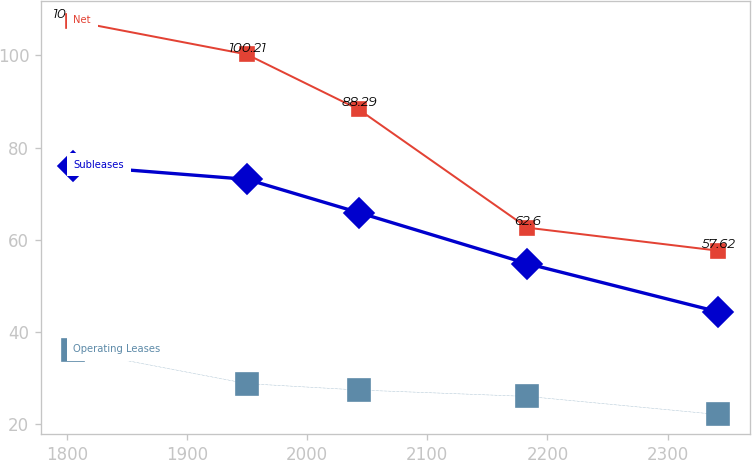Convert chart. <chart><loc_0><loc_0><loc_500><loc_500><line_chart><ecel><fcel>Net<fcel>Operating Leases<fcel>Subleases<nl><fcel>1805.34<fcel>107.44<fcel>35.97<fcel>76.06<nl><fcel>1949.84<fcel>100.21<fcel>28.75<fcel>73.1<nl><fcel>2042.79<fcel>88.29<fcel>27.36<fcel>65.89<nl><fcel>2183.26<fcel>62.6<fcel>25.97<fcel>54.79<nl><fcel>2341.69<fcel>57.62<fcel>22.05<fcel>44.36<nl></chart> 